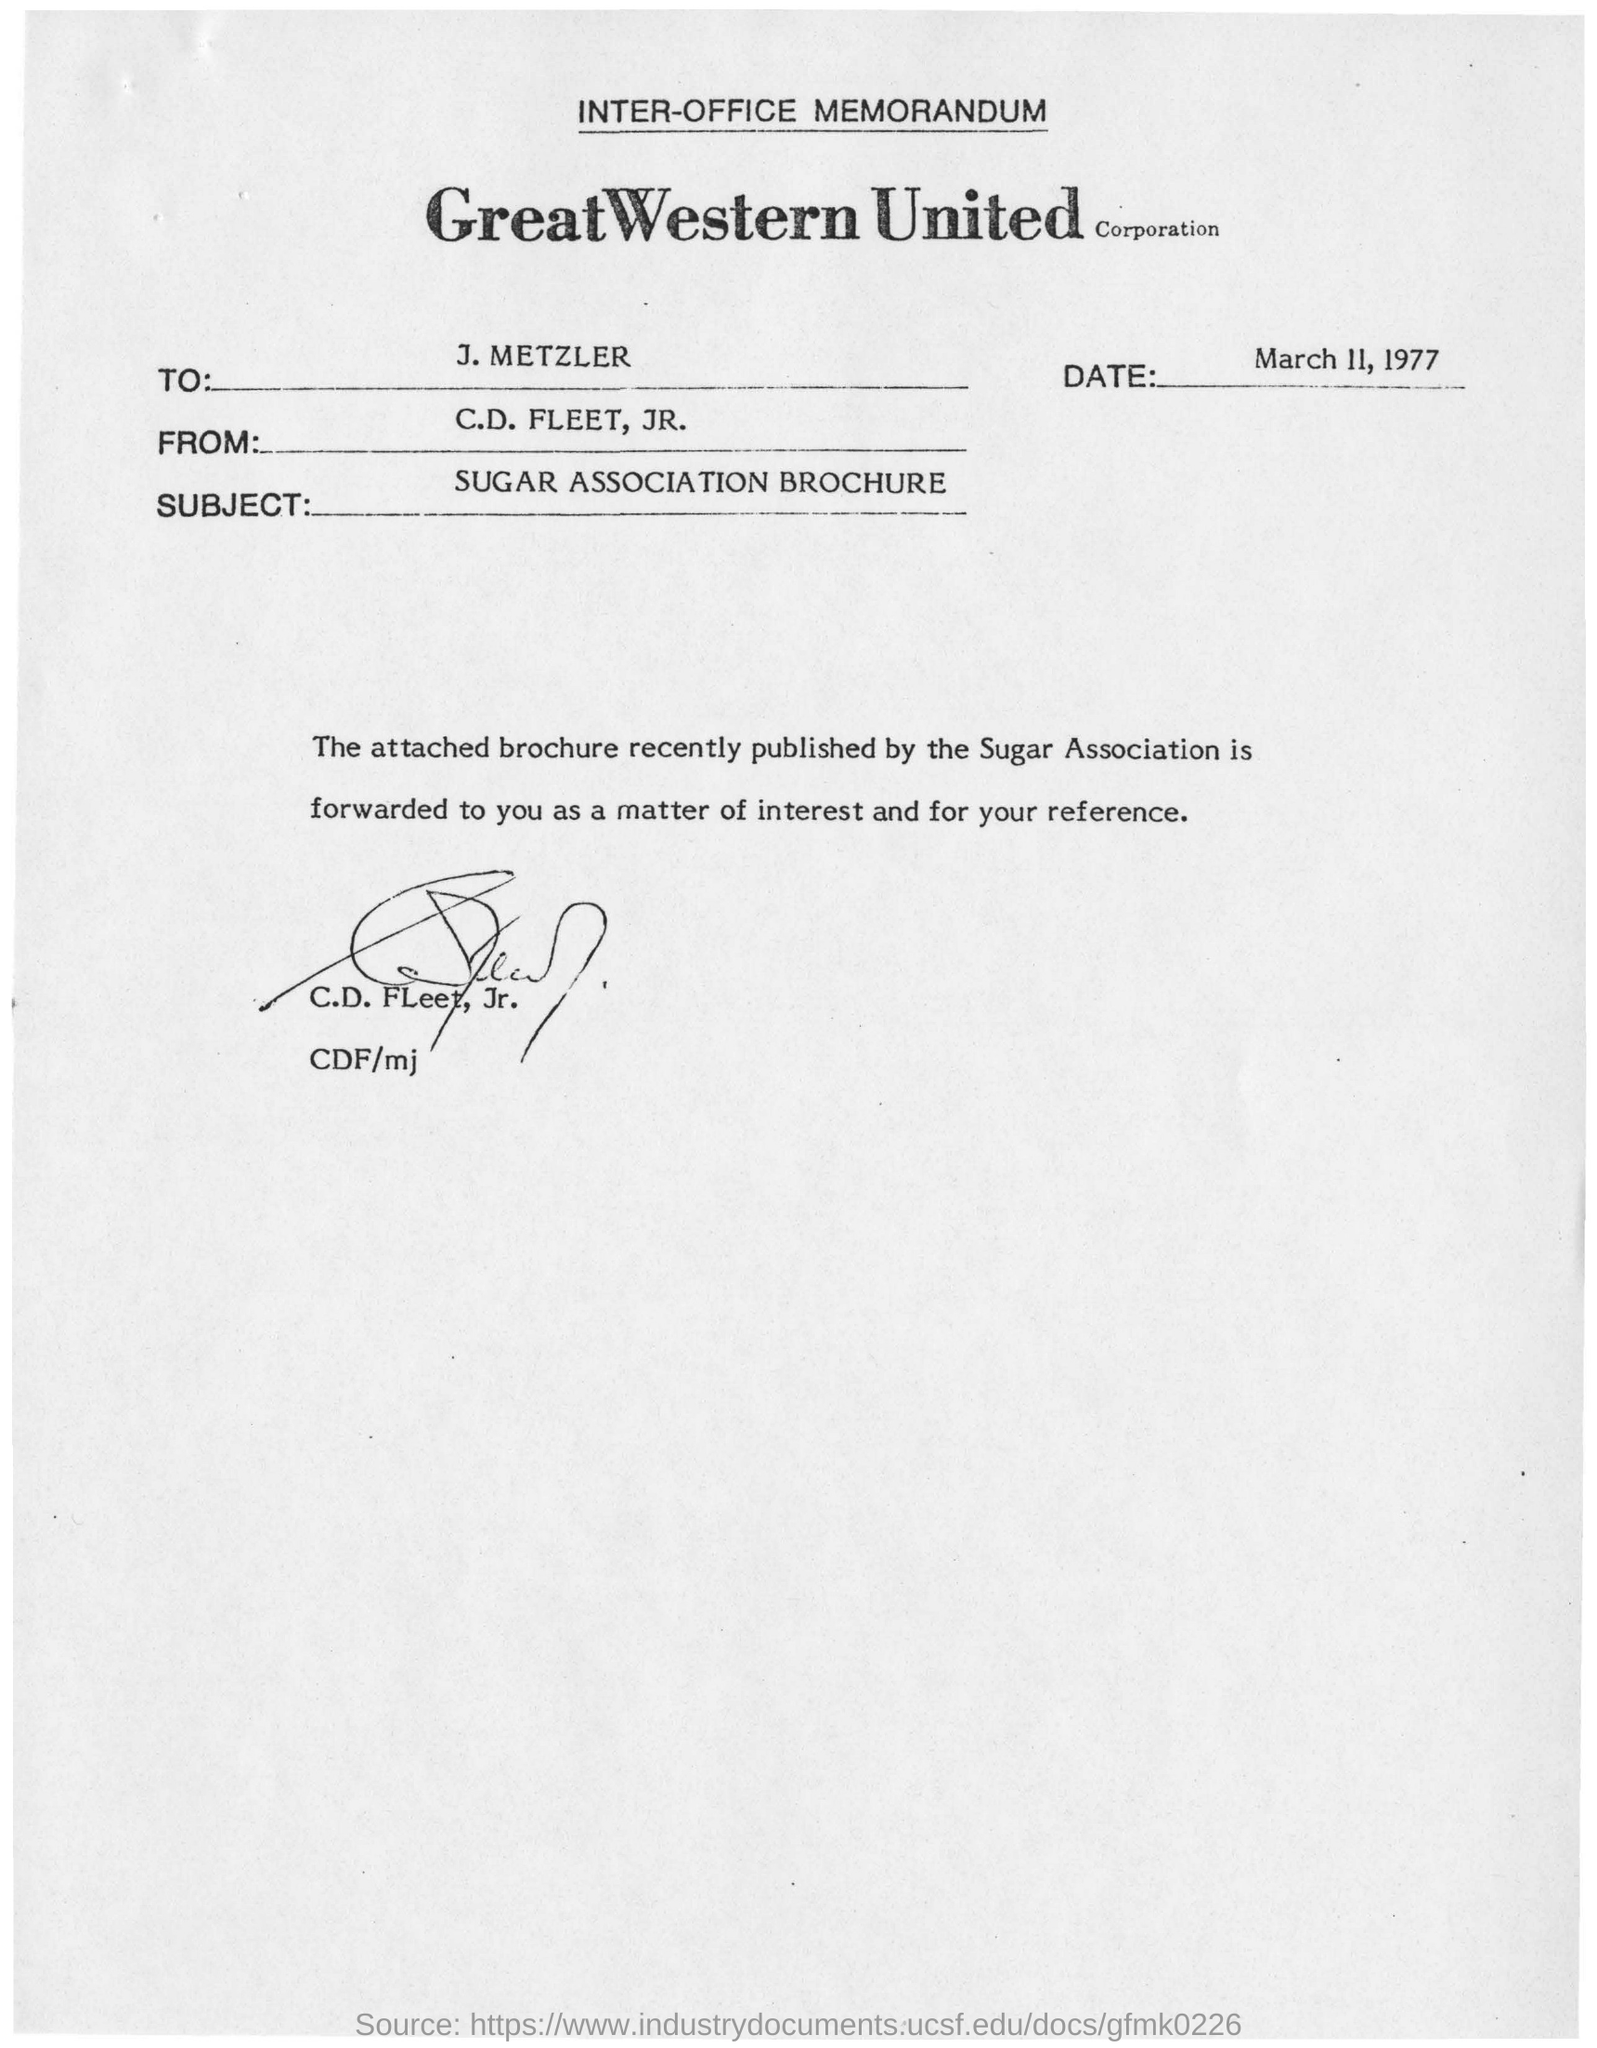Specify some key components in this picture. The corporation is named Great Western United Corporation. The sender of this memorandum is C.D. Fleet, Jr. The subject of this memorandum is the Sugar Association Broucher. The memorandum mentions that the date is March 11, 1977. The memorandum was addressed to J. Metzler. 